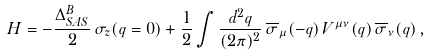<formula> <loc_0><loc_0><loc_500><loc_500>H = - \frac { \Delta ^ { B } _ { S A S } } { 2 } \, \sigma _ { z } ( { q } = 0 ) + \frac { 1 } { 2 } \int \frac { d ^ { 2 } { q } } { ( 2 \pi ) ^ { 2 } } \, \overline { \sigma } _ { \mu } ( - { q } ) \, V ^ { \mu \nu } ( { q } ) \, \overline { \sigma } _ { \nu } ( { q } ) \, ,</formula> 